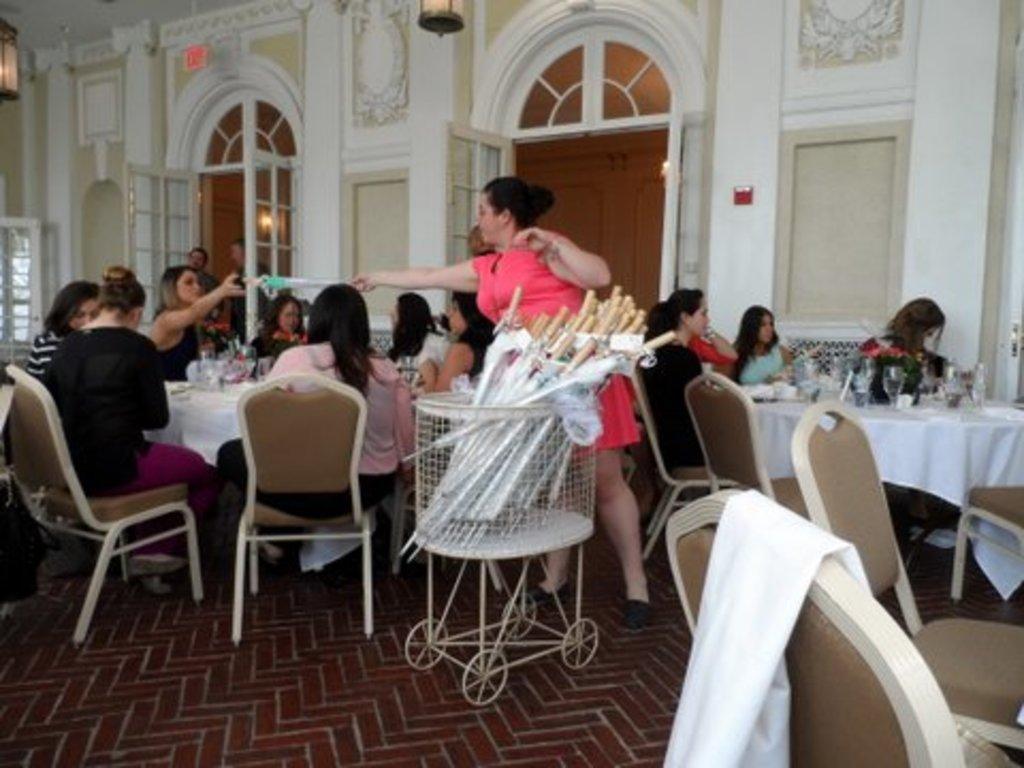In one or two sentences, can you explain what this image depicts? Here we can see a group of people sitting on chairs with tables in front of them having glasses and plates and in the center there is a woman with a trolley handing something to another woman and behind them we can see doors present 